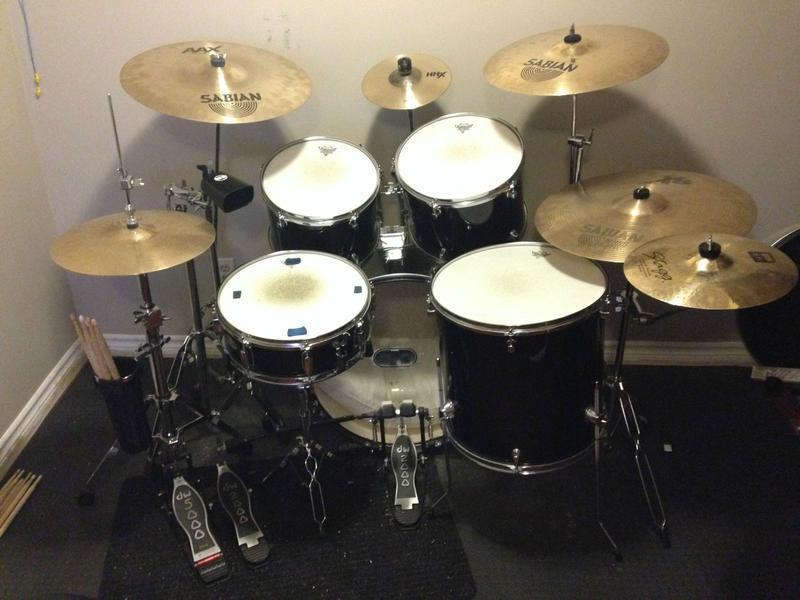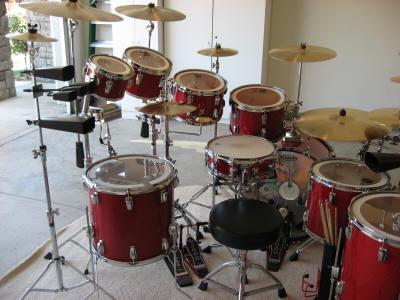The first image is the image on the left, the second image is the image on the right. For the images displayed, is the sentence "At least one image includes a hand holding a drum stick over the flat top of a drum." factually correct? Answer yes or no. No. 